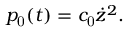Convert formula to latex. <formula><loc_0><loc_0><loc_500><loc_500>p _ { 0 } ( t ) = c _ { 0 } \dot { z } ^ { 2 } .</formula> 